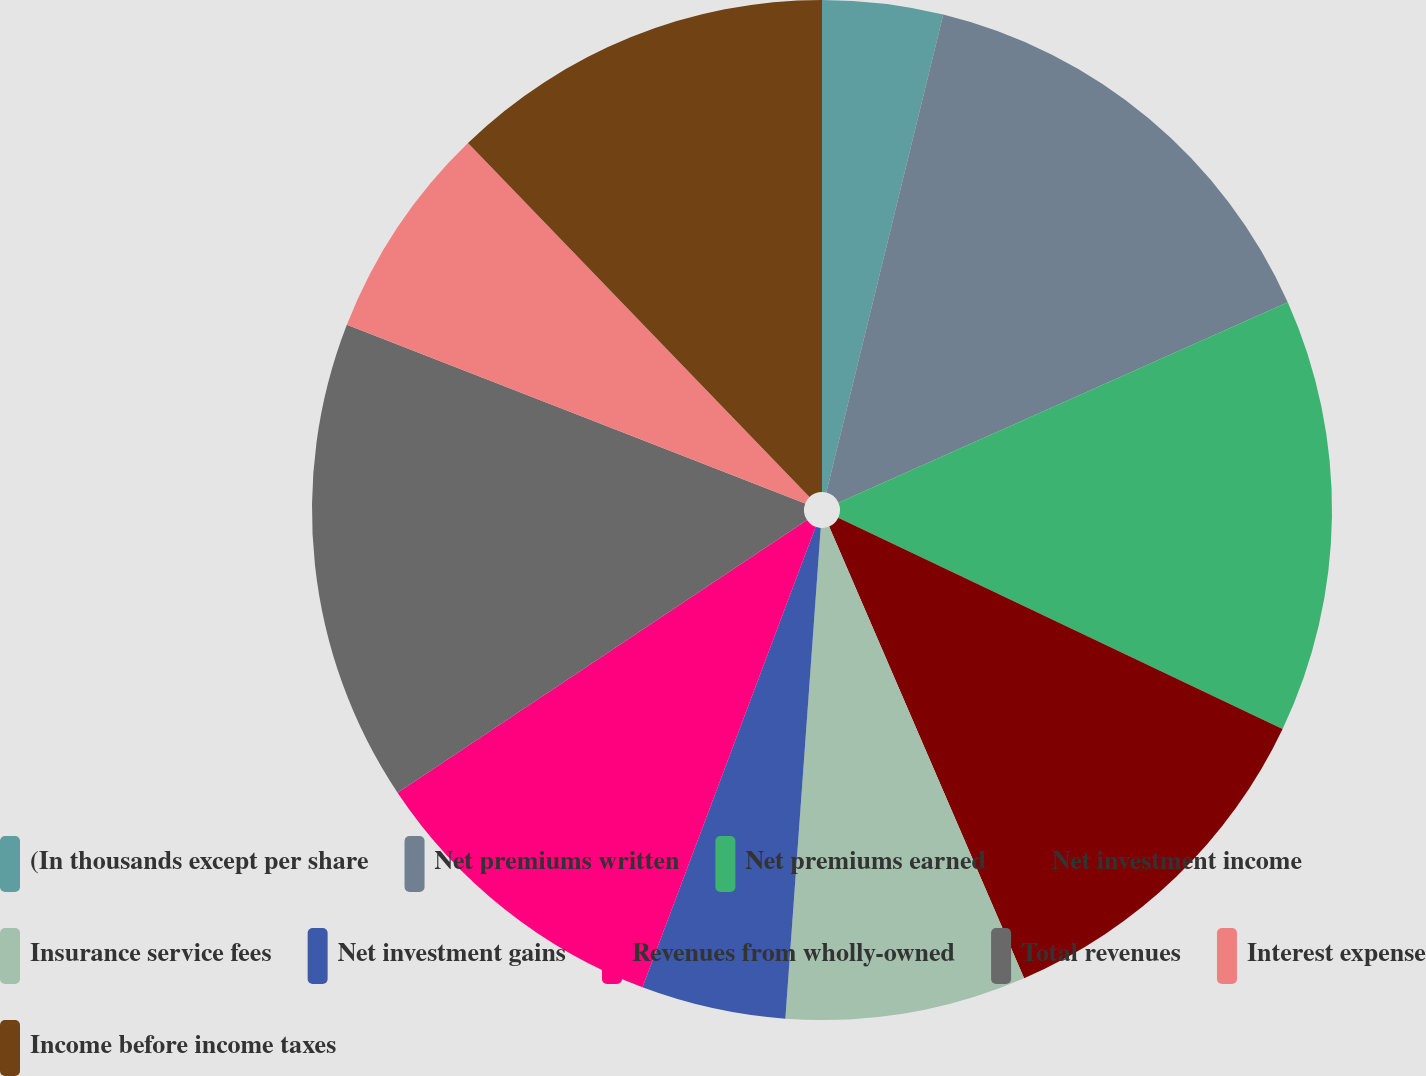<chart> <loc_0><loc_0><loc_500><loc_500><pie_chart><fcel>(In thousands except per share<fcel>Net premiums written<fcel>Net premiums earned<fcel>Net investment income<fcel>Insurance service fees<fcel>Net investment gains<fcel>Revenues from wholly-owned<fcel>Total revenues<fcel>Interest expense<fcel>Income before income taxes<nl><fcel>3.82%<fcel>14.5%<fcel>13.74%<fcel>11.45%<fcel>7.63%<fcel>4.58%<fcel>9.92%<fcel>15.27%<fcel>6.87%<fcel>12.21%<nl></chart> 